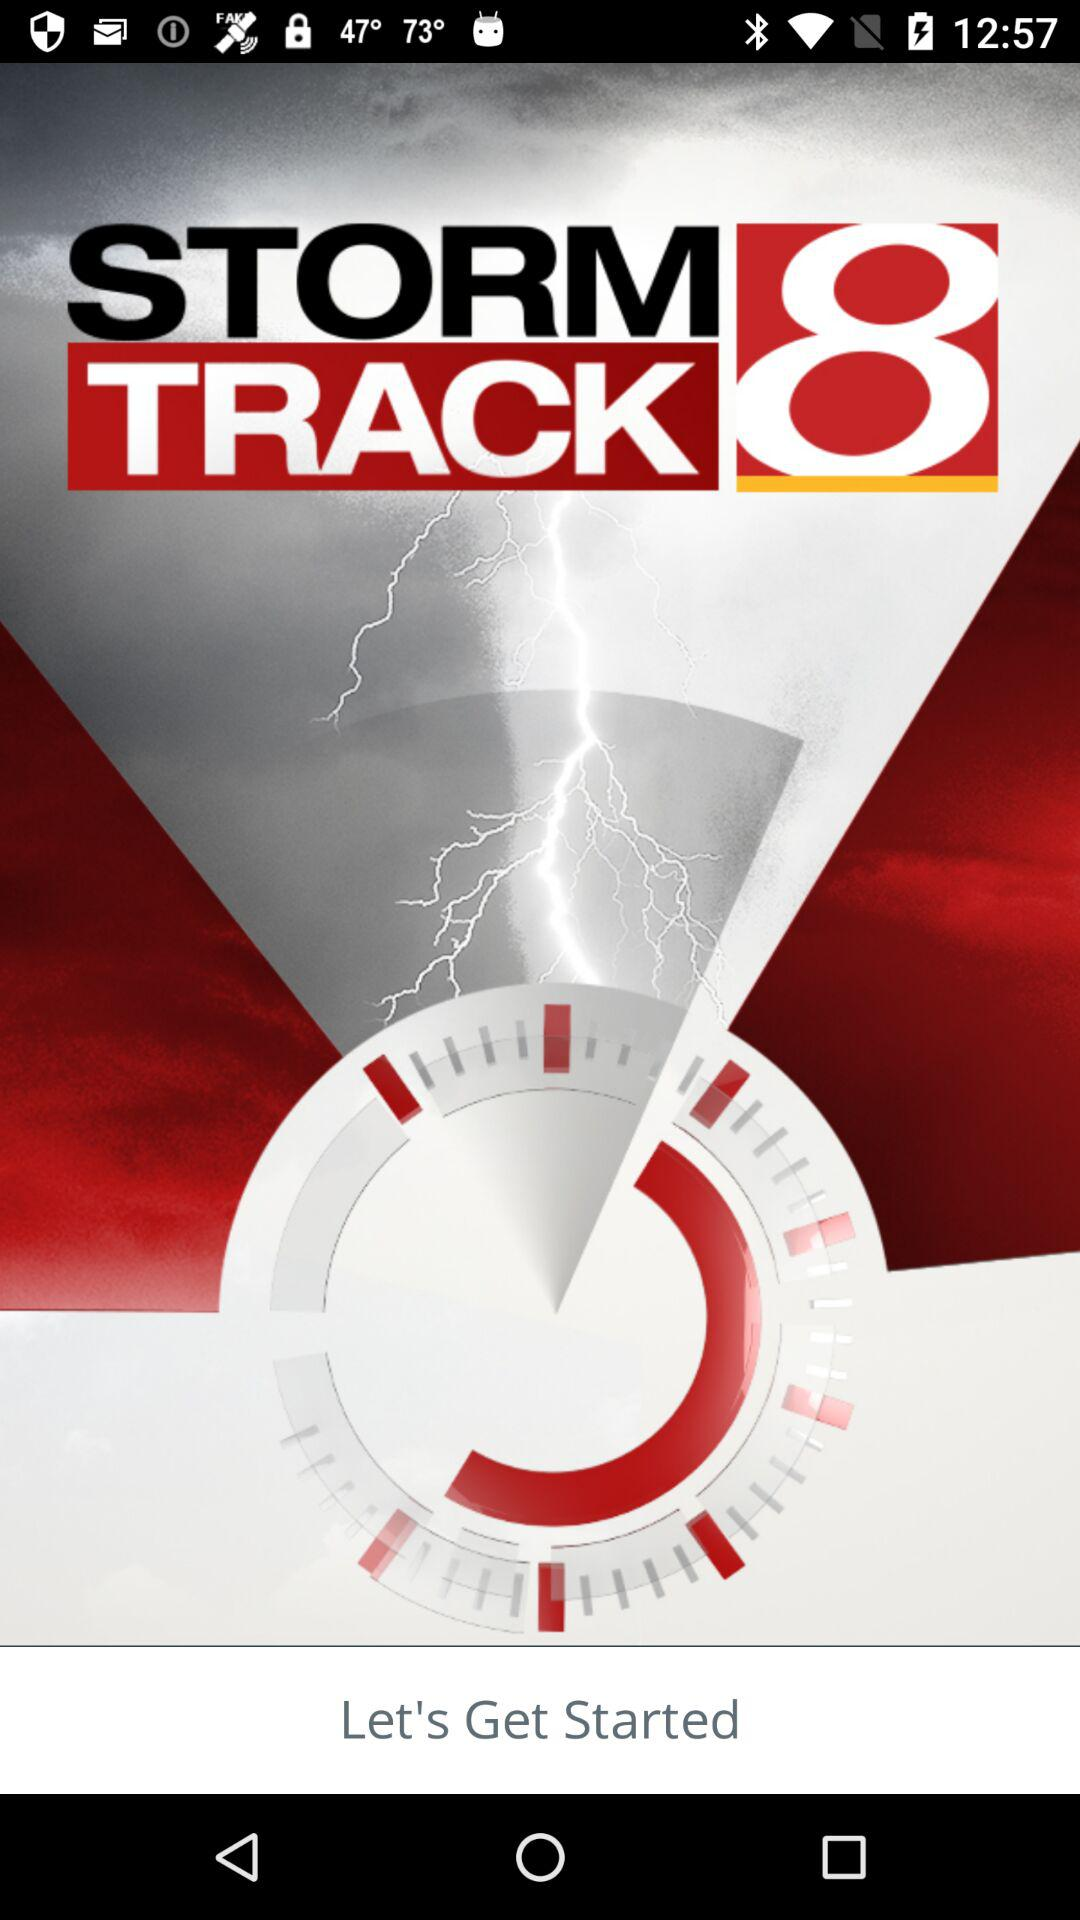What is the version of this application?
When the provided information is insufficient, respond with <no answer>. <no answer> 